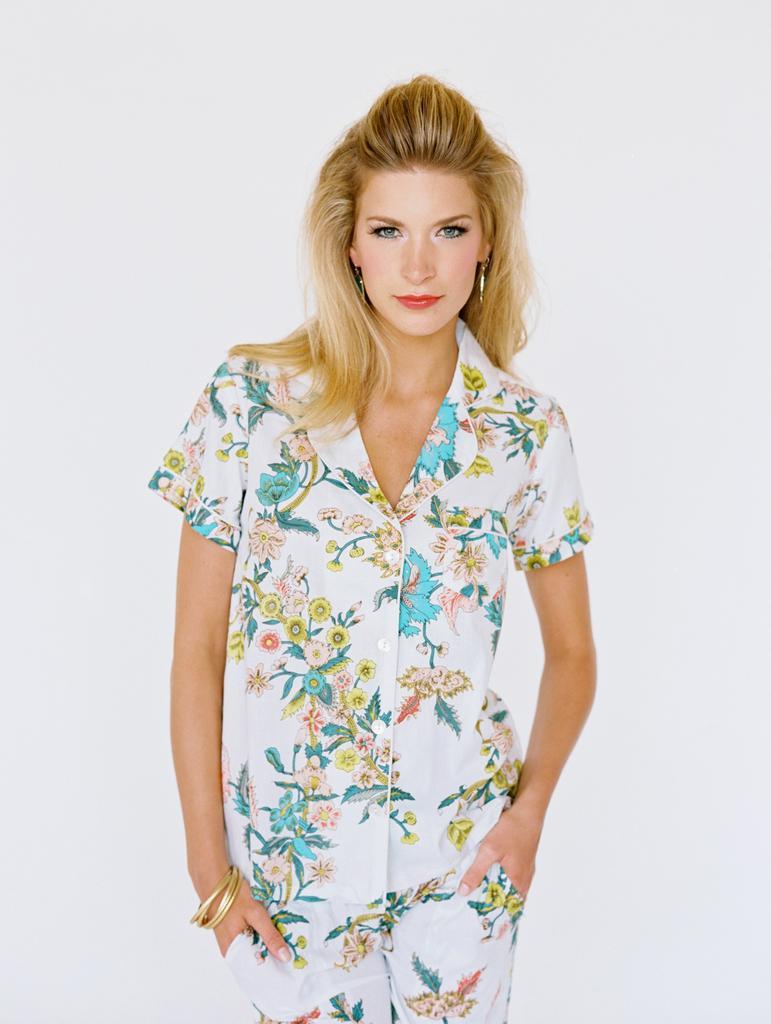Could you give a brief overview of what you see in this image? In this picture there is a woman who is wearing shirt, trouser, bangles and earrings. She is smiling. In the back I can see the white object. 